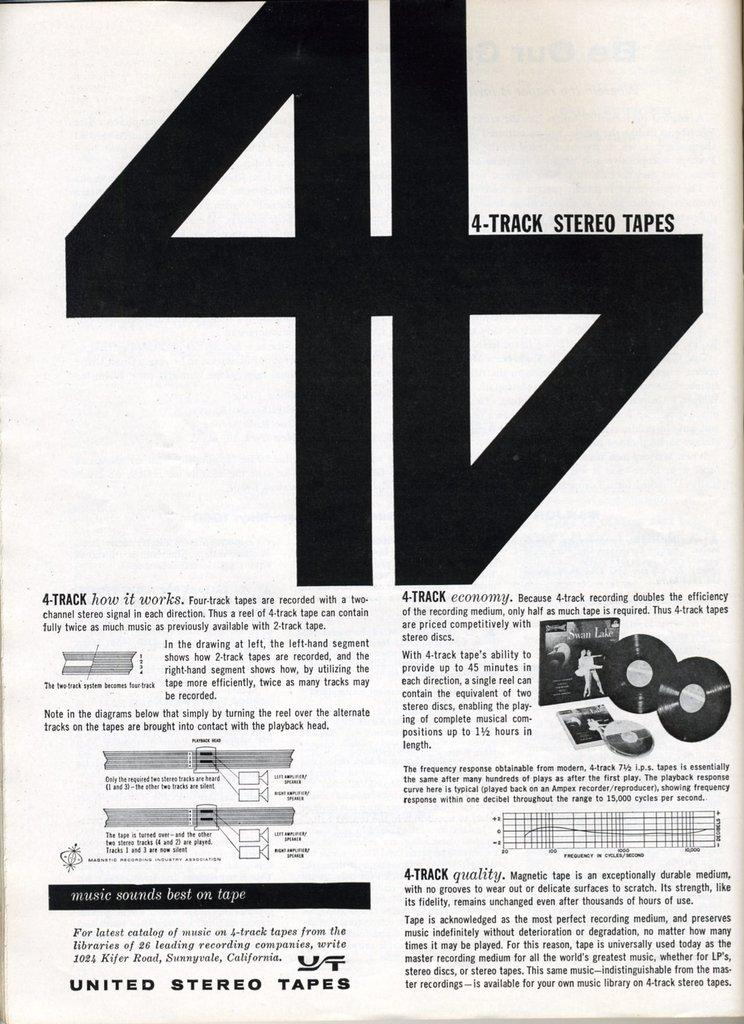<image>
Offer a succinct explanation of the picture presented. A page showing 4-track stero tapes advertising in black and white. 